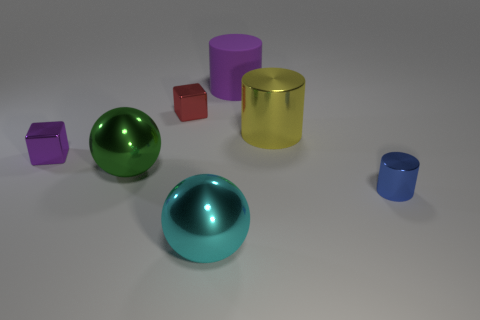Subtract all metallic cylinders. How many cylinders are left? 1 Subtract all balls. How many objects are left? 5 Add 2 blue cylinders. How many objects exist? 9 Subtract all blue cylinders. How many cylinders are left? 2 Subtract 2 cylinders. How many cylinders are left? 1 Subtract all gray cylinders. Subtract all gray cubes. How many cylinders are left? 3 Subtract all yellow spheres. How many green cubes are left? 0 Subtract all small gray metal spheres. Subtract all big cyan shiny things. How many objects are left? 6 Add 1 big green metal objects. How many big green metal objects are left? 2 Add 7 big red things. How many big red things exist? 7 